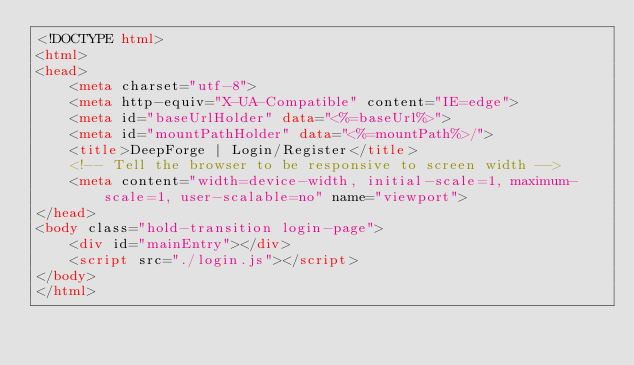<code> <loc_0><loc_0><loc_500><loc_500><_HTML_><!DOCTYPE html>
<html>
<head>
    <meta charset="utf-8">
    <meta http-equiv="X-UA-Compatible" content="IE=edge">
    <meta id="baseUrlHolder" data="<%=baseUrl%>">
    <meta id="mountPathHolder" data="<%=mountPath%>/">
    <title>DeepForge | Login/Register</title>
    <!-- Tell the browser to be responsive to screen width -->
    <meta content="width=device-width, initial-scale=1, maximum-scale=1, user-scalable=no" name="viewport">
</head>
<body class="hold-transition login-page">
    <div id="mainEntry"></div>
    <script src="./login.js"></script>
</body>
</html>
</code> 